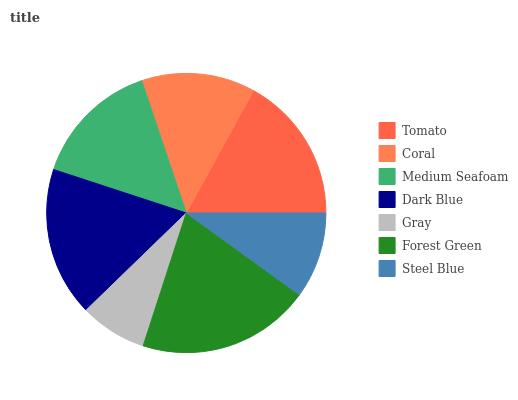Is Gray the minimum?
Answer yes or no. Yes. Is Forest Green the maximum?
Answer yes or no. Yes. Is Coral the minimum?
Answer yes or no. No. Is Coral the maximum?
Answer yes or no. No. Is Tomato greater than Coral?
Answer yes or no. Yes. Is Coral less than Tomato?
Answer yes or no. Yes. Is Coral greater than Tomato?
Answer yes or no. No. Is Tomato less than Coral?
Answer yes or no. No. Is Medium Seafoam the high median?
Answer yes or no. Yes. Is Medium Seafoam the low median?
Answer yes or no. Yes. Is Steel Blue the high median?
Answer yes or no. No. Is Coral the low median?
Answer yes or no. No. 